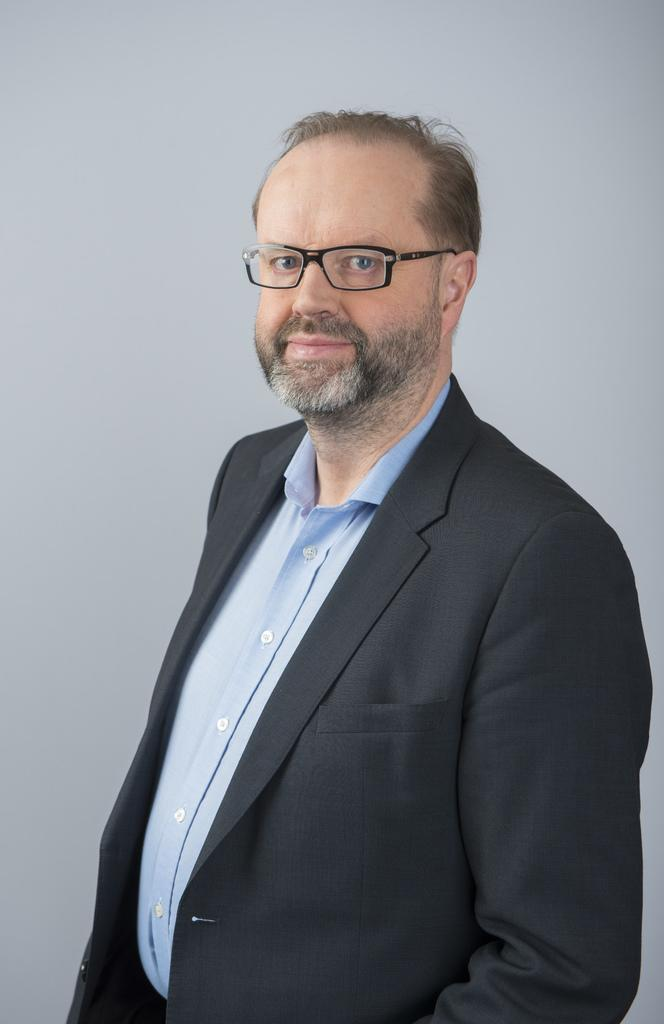What is the main subject of the image? There is a person standing in the center of the image. What is the person wearing in the image? The person is wearing a different costume. Are there any accessories visible on the person? Yes, the person is wearing glasses. What is the color of the background in the image? The background of the image is white. Can you tell me how many plants are visible in the image? There are no plants visible in the image; it features a person standing in the center with a white background. What type of wound can be seen on the person's face in the image? There is no wound visible on the person's face in the image. 